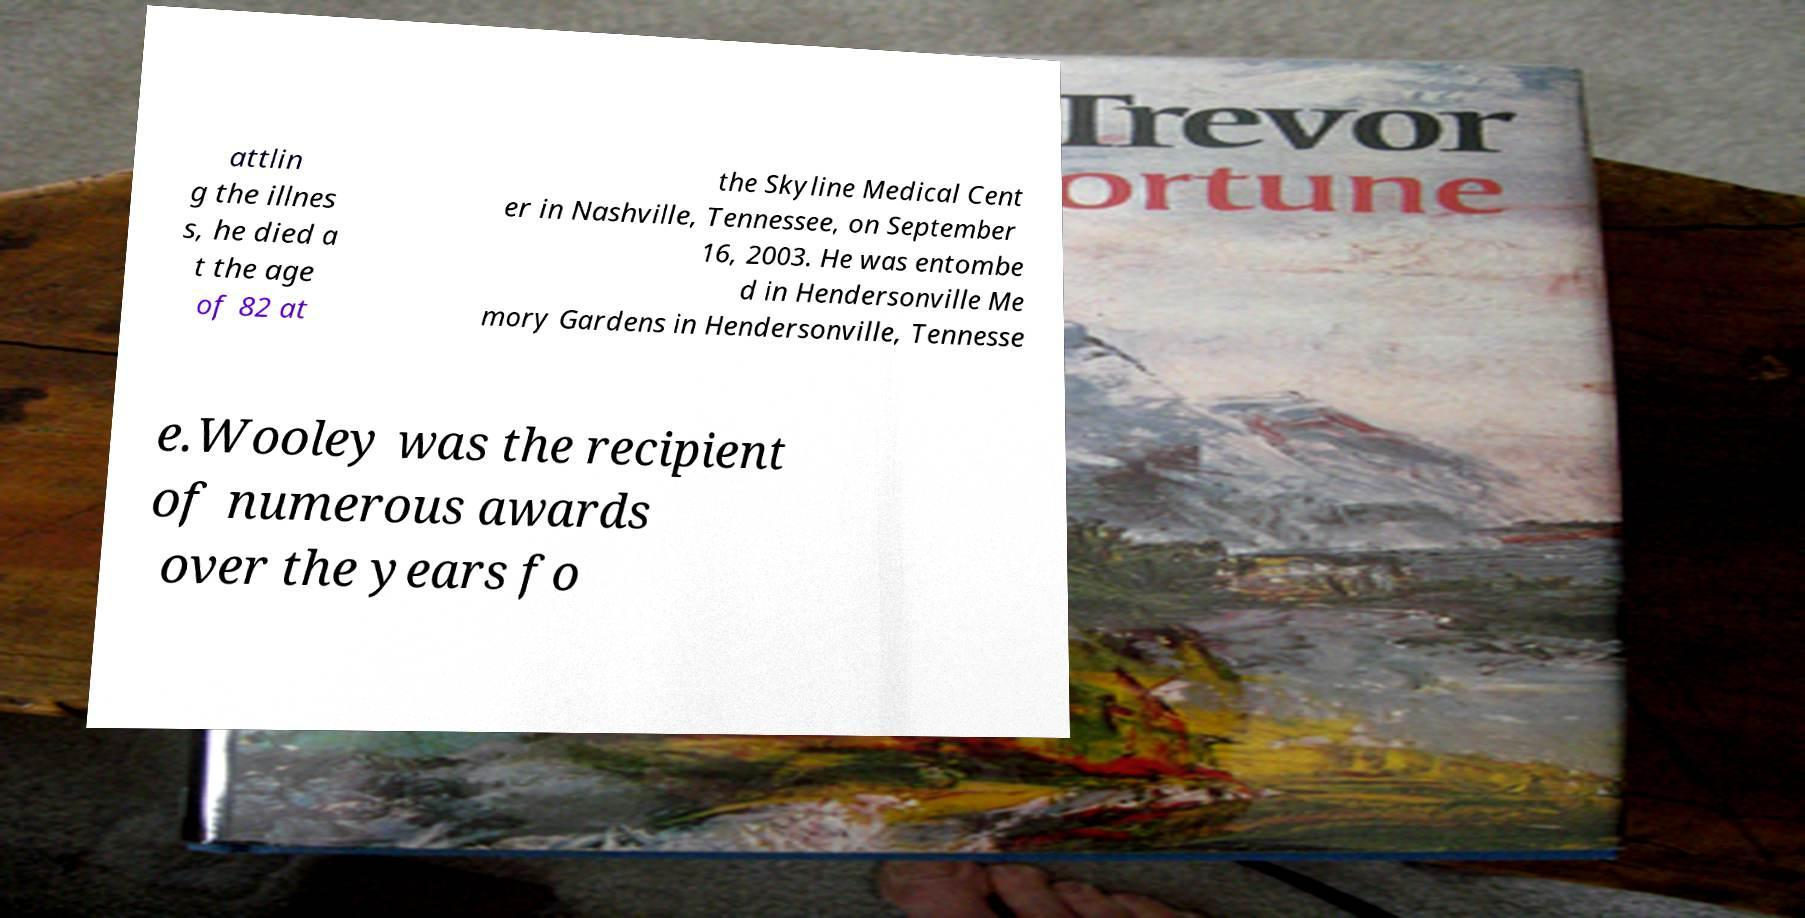Please identify and transcribe the text found in this image. attlin g the illnes s, he died a t the age of 82 at the Skyline Medical Cent er in Nashville, Tennessee, on September 16, 2003. He was entombe d in Hendersonville Me mory Gardens in Hendersonville, Tennesse e.Wooley was the recipient of numerous awards over the years fo 